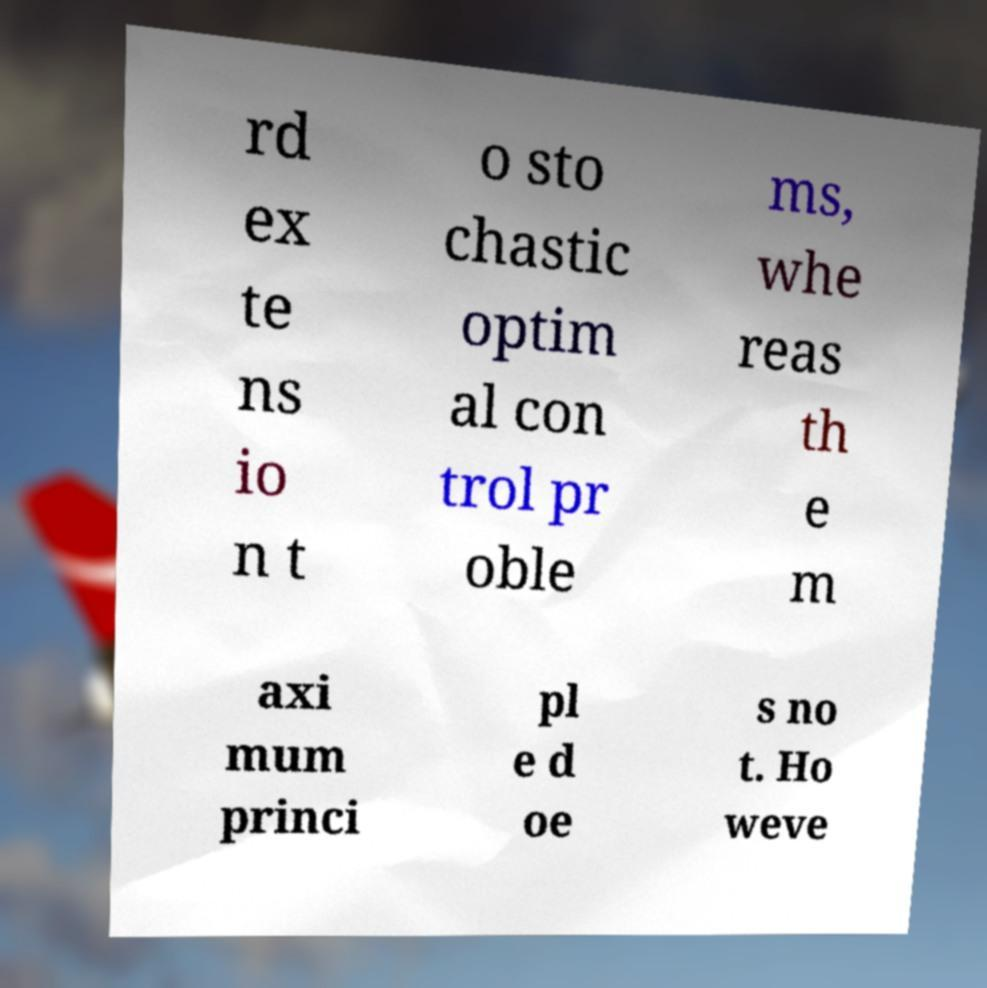I need the written content from this picture converted into text. Can you do that? rd ex te ns io n t o sto chastic optim al con trol pr oble ms, whe reas th e m axi mum princi pl e d oe s no t. Ho weve 